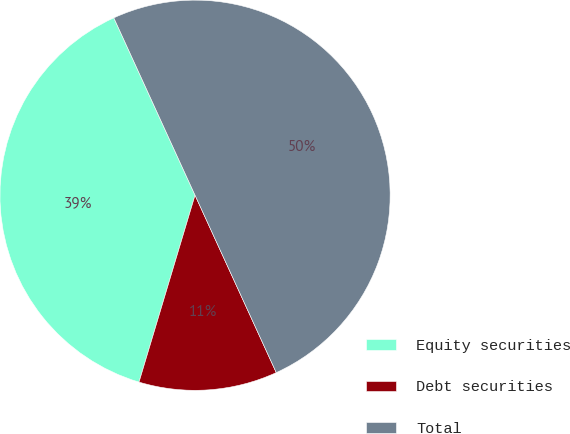<chart> <loc_0><loc_0><loc_500><loc_500><pie_chart><fcel>Equity securities<fcel>Debt securities<fcel>Total<nl><fcel>38.53%<fcel>11.47%<fcel>50.0%<nl></chart> 